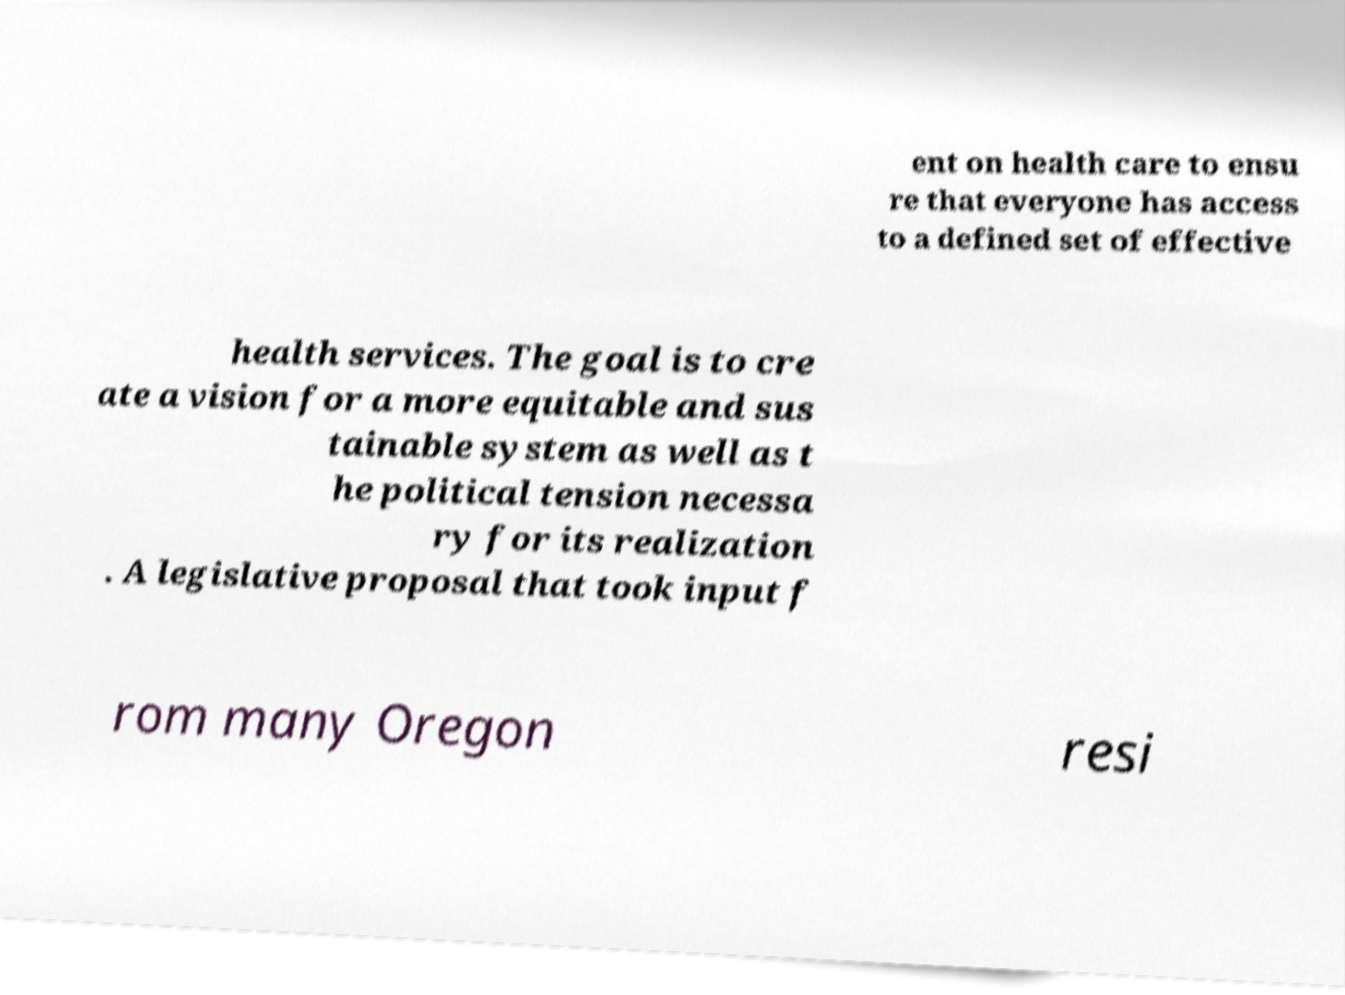What messages or text are displayed in this image? I need them in a readable, typed format. ent on health care to ensu re that everyone has access to a defined set of effective health services. The goal is to cre ate a vision for a more equitable and sus tainable system as well as t he political tension necessa ry for its realization . A legislative proposal that took input f rom many Oregon resi 